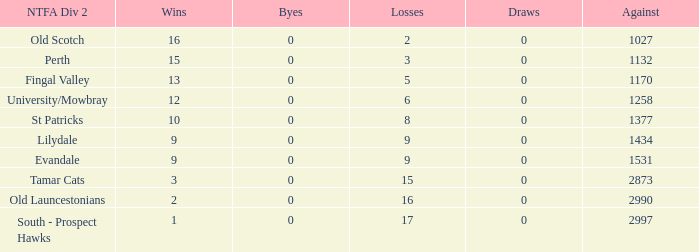What is the lowest number of against of NTFA Div 2 Fingal Valley? 1170.0. 